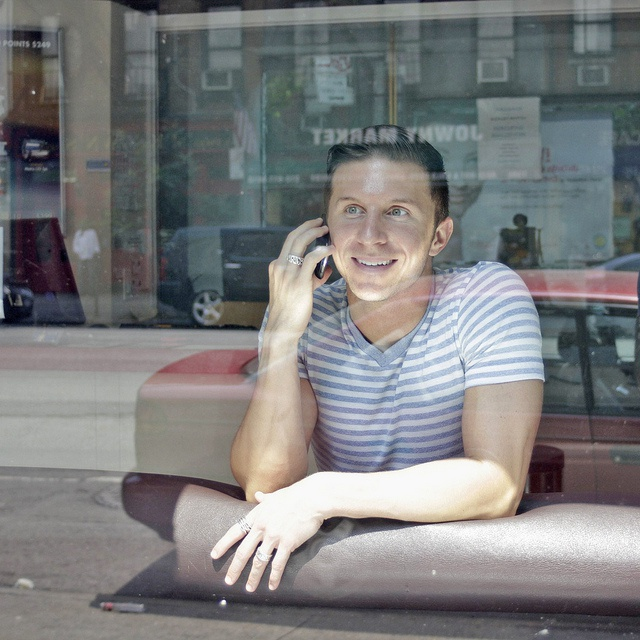Describe the objects in this image and their specific colors. I can see people in gray, darkgray, white, and tan tones, car in gray, black, darkgray, and purple tones, car in gray, blue, black, and darkblue tones, people in gray, darkgray, and black tones, and car in gray, black, and darkgray tones in this image. 